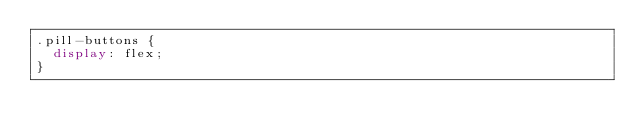<code> <loc_0><loc_0><loc_500><loc_500><_CSS_>.pill-buttons {
  display: flex;
}
</code> 